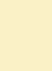<code> <loc_0><loc_0><loc_500><loc_500><_Python_>
</code> 